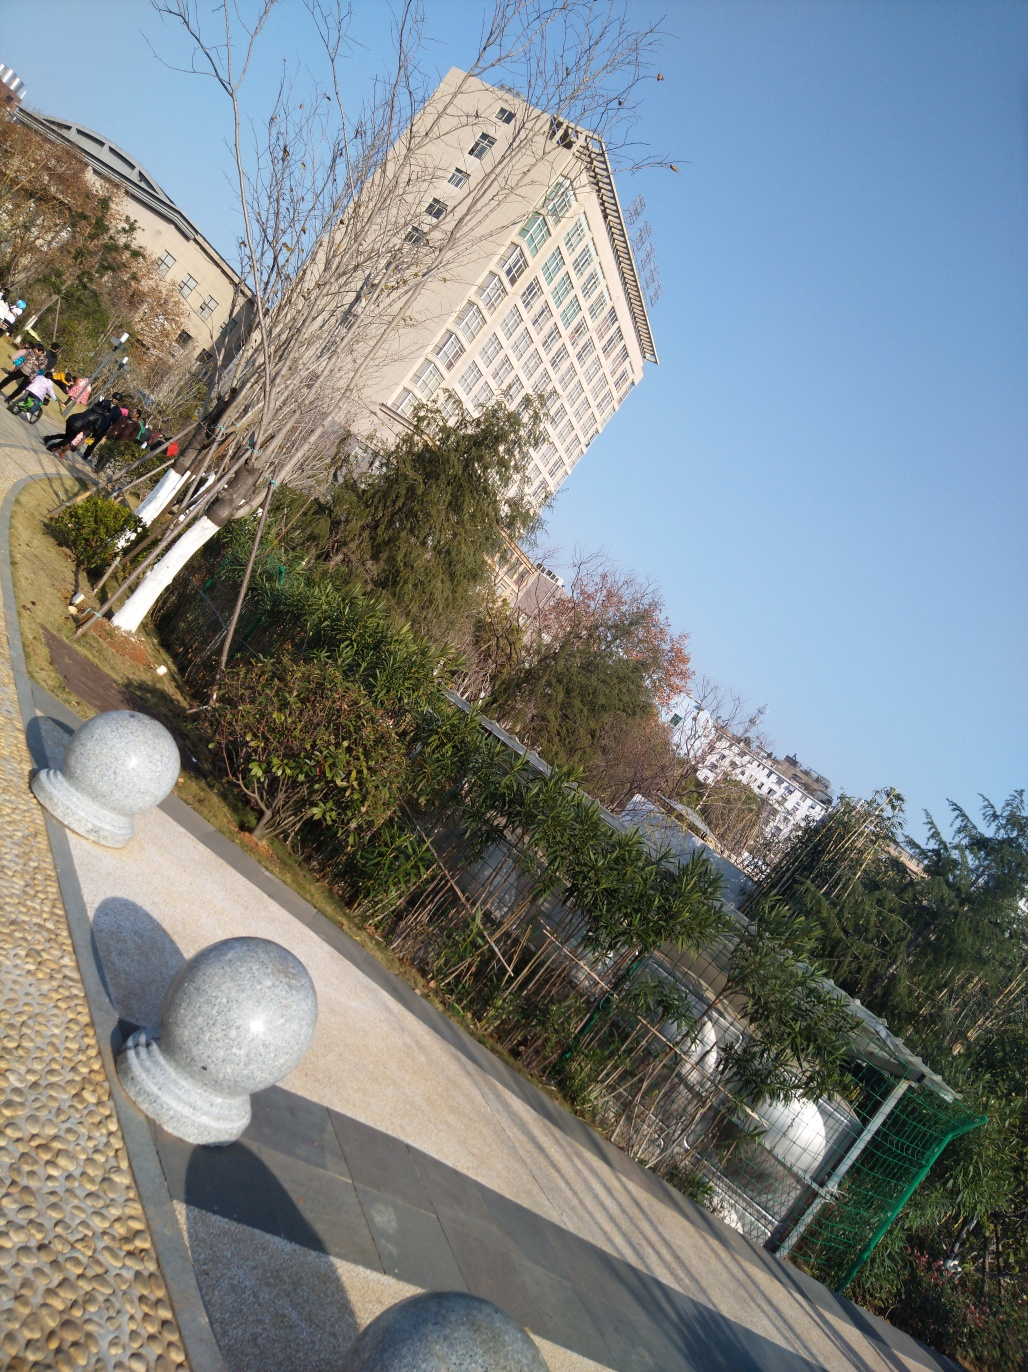What kind of public or private space could this be? Based on the visible elements, such as the walkway, the orderly placed bollards, and the managed vegetation, this space appears to be a part of a public area, possibly within a larger urban complex like a university campus or a business park. The presence of benches and the open space suggest it's designed for pedestrians to enjoy a leisurely walk or rest. 